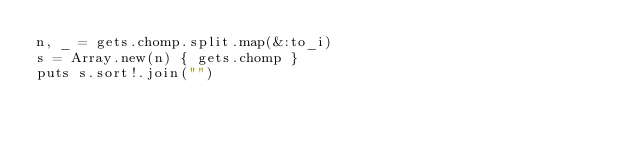<code> <loc_0><loc_0><loc_500><loc_500><_Ruby_>n, _ = gets.chomp.split.map(&:to_i)
s = Array.new(n) { gets.chomp }
puts s.sort!.join("")</code> 